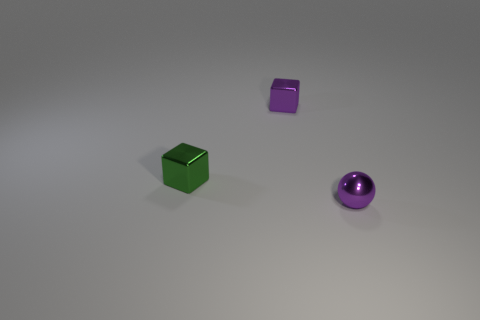There is a shiny sphere that is the same size as the green thing; what is its color?
Give a very brief answer. Purple. How many big red metal blocks are there?
Ensure brevity in your answer.  0. Is the material of the thing that is behind the green metal block the same as the purple ball?
Ensure brevity in your answer.  Yes. What material is the small thing that is left of the tiny purple sphere and in front of the purple shiny cube?
Provide a succinct answer. Metal. There is a metallic object that is the same color as the metallic ball; what size is it?
Your answer should be very brief. Small. There is a small object to the right of the purple object that is behind the small purple metal sphere; what is its material?
Offer a very short reply. Metal. There is a purple object left of the shiny object right of the purple metallic thing that is behind the green metal object; what size is it?
Offer a very short reply. Small. What number of other small blocks are made of the same material as the small purple block?
Make the answer very short. 1. What is the color of the object to the left of the purple thing behind the purple metallic sphere?
Your answer should be compact. Green. How many objects are green things or purple things that are behind the tiny green object?
Offer a terse response. 2. 